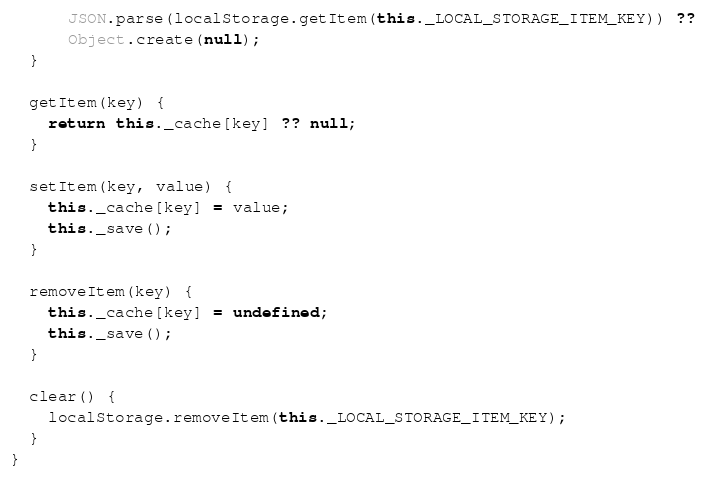Convert code to text. <code><loc_0><loc_0><loc_500><loc_500><_JavaScript_>      JSON.parse(localStorage.getItem(this._LOCAL_STORAGE_ITEM_KEY)) ??
      Object.create(null);
  }

  getItem(key) {
    return this._cache[key] ?? null;
  }

  setItem(key, value) {
    this._cache[key] = value;
    this._save();
  }

  removeItem(key) {
    this._cache[key] = undefined;
    this._save();
  }

  clear() {
    localStorage.removeItem(this._LOCAL_STORAGE_ITEM_KEY);
  }
}
</code> 